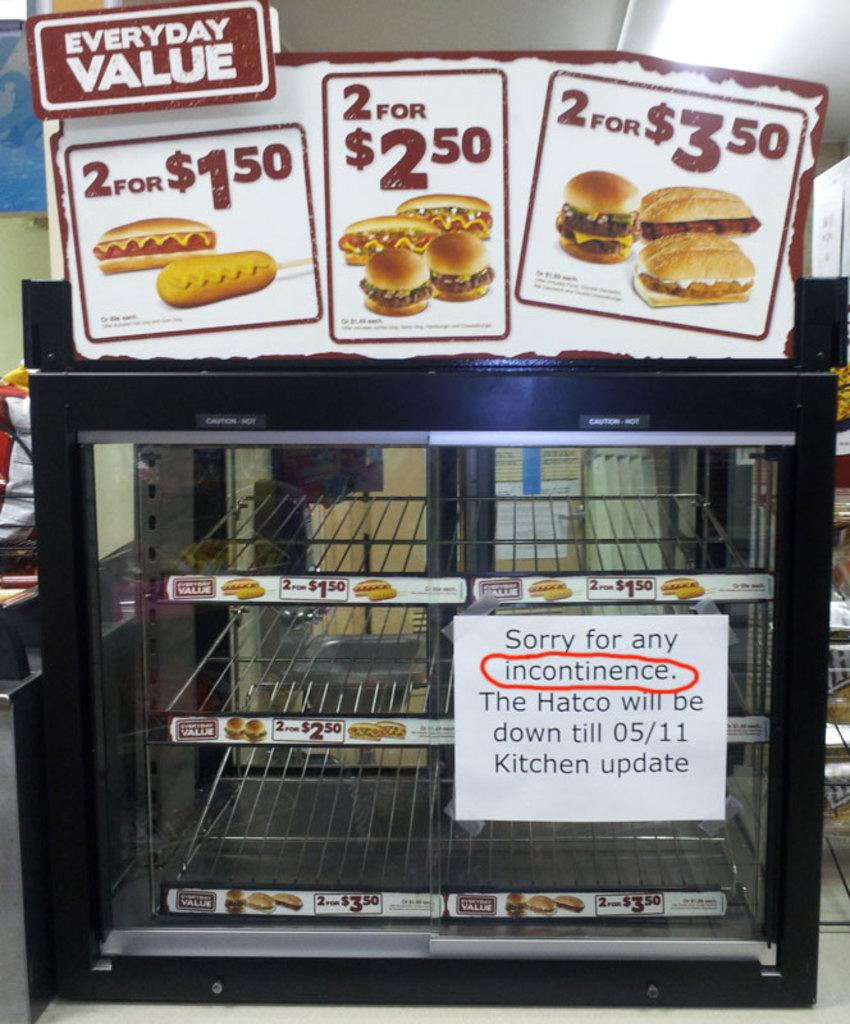<image>
Give a short and clear explanation of the subsequent image. a sign that says value on the front 